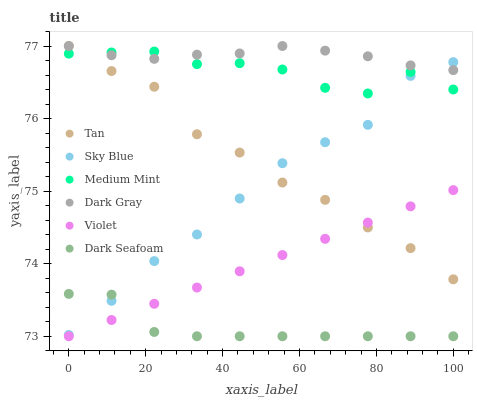Does Dark Seafoam have the minimum area under the curve?
Answer yes or no. Yes. Does Dark Gray have the maximum area under the curve?
Answer yes or no. Yes. Does Dark Gray have the minimum area under the curve?
Answer yes or no. No. Does Dark Seafoam have the maximum area under the curve?
Answer yes or no. No. Is Violet the smoothest?
Answer yes or no. Yes. Is Medium Mint the roughest?
Answer yes or no. Yes. Is Dark Gray the smoothest?
Answer yes or no. No. Is Dark Gray the roughest?
Answer yes or no. No. Does Dark Seafoam have the lowest value?
Answer yes or no. Yes. Does Dark Gray have the lowest value?
Answer yes or no. No. Does Tan have the highest value?
Answer yes or no. Yes. Does Dark Seafoam have the highest value?
Answer yes or no. No. Is Violet less than Dark Gray?
Answer yes or no. Yes. Is Medium Mint greater than Violet?
Answer yes or no. Yes. Does Sky Blue intersect Medium Mint?
Answer yes or no. Yes. Is Sky Blue less than Medium Mint?
Answer yes or no. No. Is Sky Blue greater than Medium Mint?
Answer yes or no. No. Does Violet intersect Dark Gray?
Answer yes or no. No. 